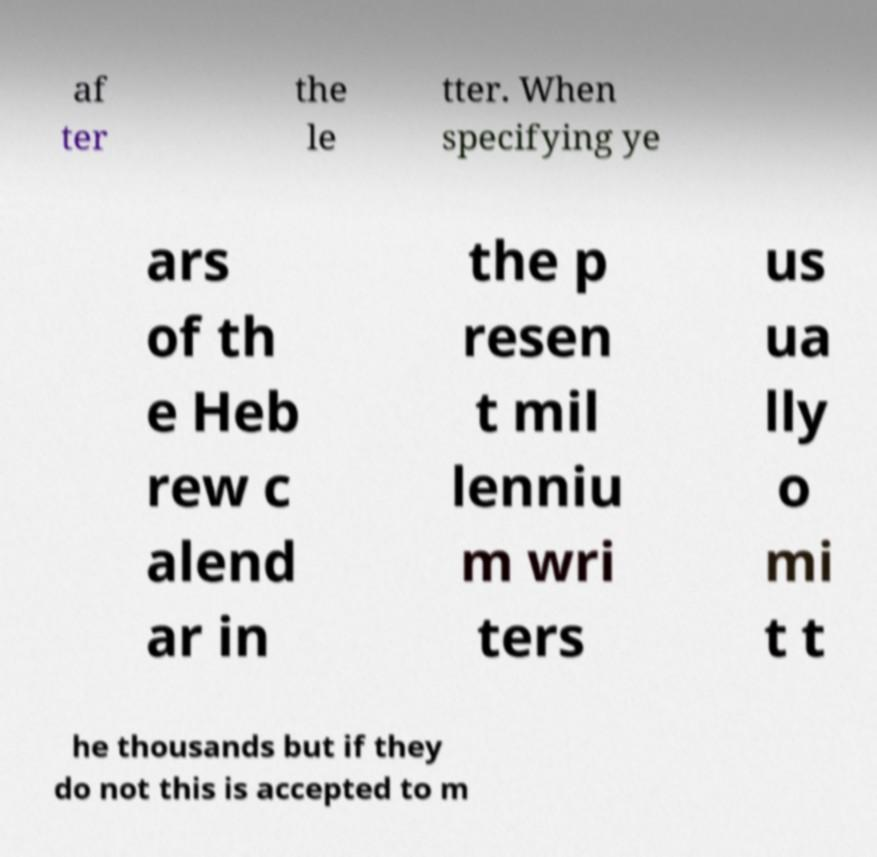Can you accurately transcribe the text from the provided image for me? af ter the le tter. When specifying ye ars of th e Heb rew c alend ar in the p resen t mil lenniu m wri ters us ua lly o mi t t he thousands but if they do not this is accepted to m 